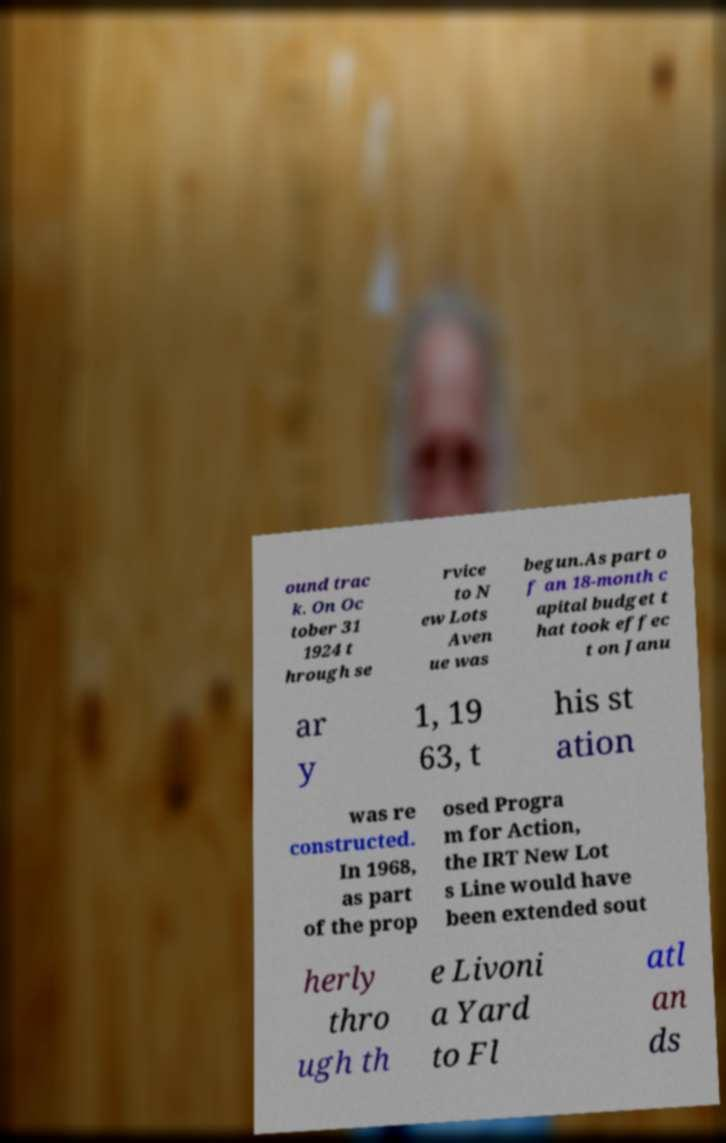Could you assist in decoding the text presented in this image and type it out clearly? ound trac k. On Oc tober 31 1924 t hrough se rvice to N ew Lots Aven ue was begun.As part o f an 18-month c apital budget t hat took effec t on Janu ar y 1, 19 63, t his st ation was re constructed. In 1968, as part of the prop osed Progra m for Action, the IRT New Lot s Line would have been extended sout herly thro ugh th e Livoni a Yard to Fl atl an ds 